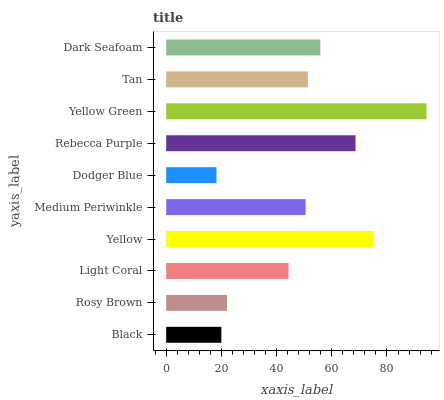Is Dodger Blue the minimum?
Answer yes or no. Yes. Is Yellow Green the maximum?
Answer yes or no. Yes. Is Rosy Brown the minimum?
Answer yes or no. No. Is Rosy Brown the maximum?
Answer yes or no. No. Is Rosy Brown greater than Black?
Answer yes or no. Yes. Is Black less than Rosy Brown?
Answer yes or no. Yes. Is Black greater than Rosy Brown?
Answer yes or no. No. Is Rosy Brown less than Black?
Answer yes or no. No. Is Tan the high median?
Answer yes or no. Yes. Is Medium Periwinkle the low median?
Answer yes or no. Yes. Is Medium Periwinkle the high median?
Answer yes or no. No. Is Rebecca Purple the low median?
Answer yes or no. No. 